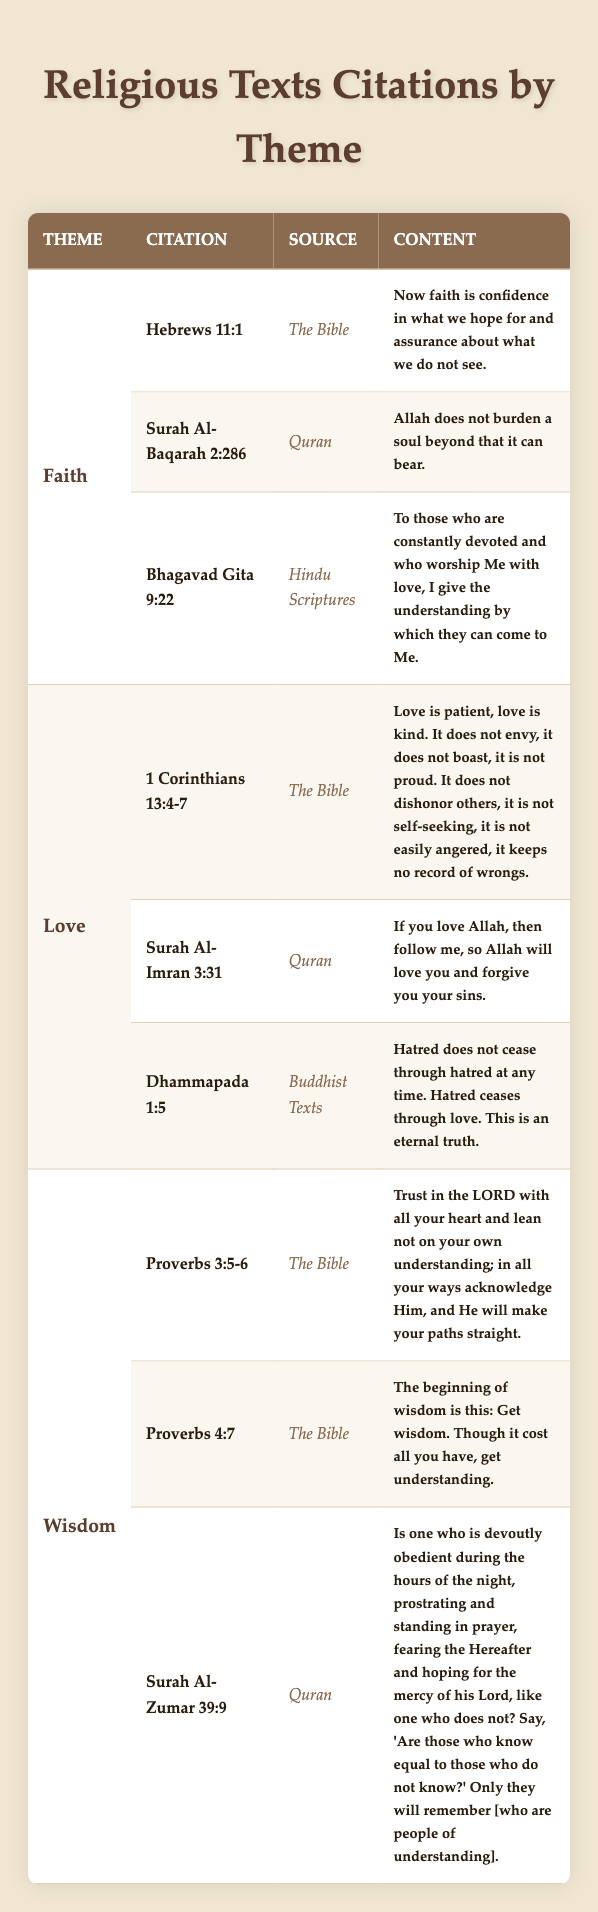What is the theme for the citation "Surah Al-Baqarah 2:286"? The citation "Surah Al-Baqarah 2:286" is listed under the "Faith" theme in the table.
Answer: Faith How many citations are there under the theme of Love? There are three citations listed under the theme of Love (1 Corinthians 13:4-7, Surah Al-Imran 3:31, Dhammapada 1:5).
Answer: 3 Is "Proverbs 4:7" from the Quran? No, "Proverbs 4:7" is from The Bible, not from the Quran.
Answer: No Which source includes the citation "Dhammapada 1:5"? The source for the citation "Dhammapada 1:5" is listed as "Buddhist Texts" in the table.
Answer: Buddhist Texts Which theme has the most citations? Each theme (Faith, Love, and Wisdom) has an equal number of three citations, so none has more than the others.
Answer: None What are the sources for the citations under the theme of Wisdom? The sources for the Wisdom citations are The Bible for Proverbs 3:5-6 and Proverbs 4:7, and the Quran for Surah Al-Zumar 39:9.
Answer: The Bible, Quran Identify the citations that mention the concept of love. The citations mentioning love are "1 Corinthians 13:4-7," "Surah Al-Imran 3:31," and "Dhammapada 1:5."
Answer: 1 Corinthians 13:4-7, Surah Al-Imran 3:31, Dhammapada 1:5 Which citation has the content "Hatred does not cease through hatred at any time"? The content "Hatred does not cease through hatred at any time" belongs to the citation "Dhammapada 1:5."
Answer: Dhammapada 1:5 How does the citation from the Quran in the theme of Faith relate to the concept of belief? The citation "Surah Al-Baqarah 2:286" states that Allah does not burden a soul beyond what it can bear, which encourages belief in divine support. This shows a connection between faith and the understanding of personal capacity in trials.
Answer: Encourages belief in divine support Which citation emphasizes the importance of understanding in the theme of Wisdom? The citation "Proverbs 4:7," which states, "The beginning of wisdom is this: Get wisdom. Though it cost all you have, get understanding," emphasizes the importance of understanding.
Answer: Proverbs 4:7 What is the relationship between the themes of Love and Faith based on the citations? The themes of Love and Faith are interconnected as both emphasize core spiritual values; love is seen as a manifestation of faith, encouraging devotion and understanding in both the Bible and Quran.
Answer: Interconnected; love manifests faith 